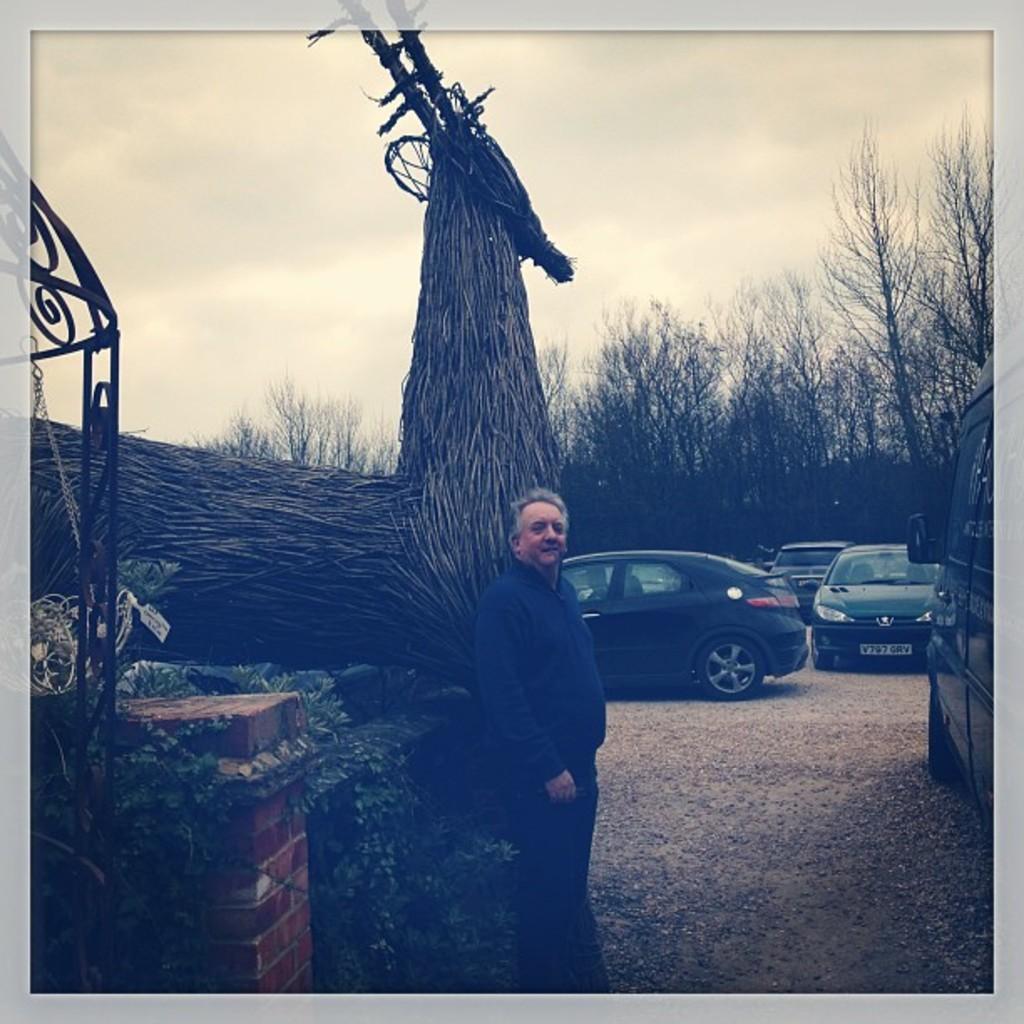How would you summarize this image in a sentence or two? In this image we can see a person wearing blue color dress standing near the wall, there are some vehicles parked on the road, in the foreground of the image there is a wall, plants and in the background of the image there are some trees, cloudy sky. 